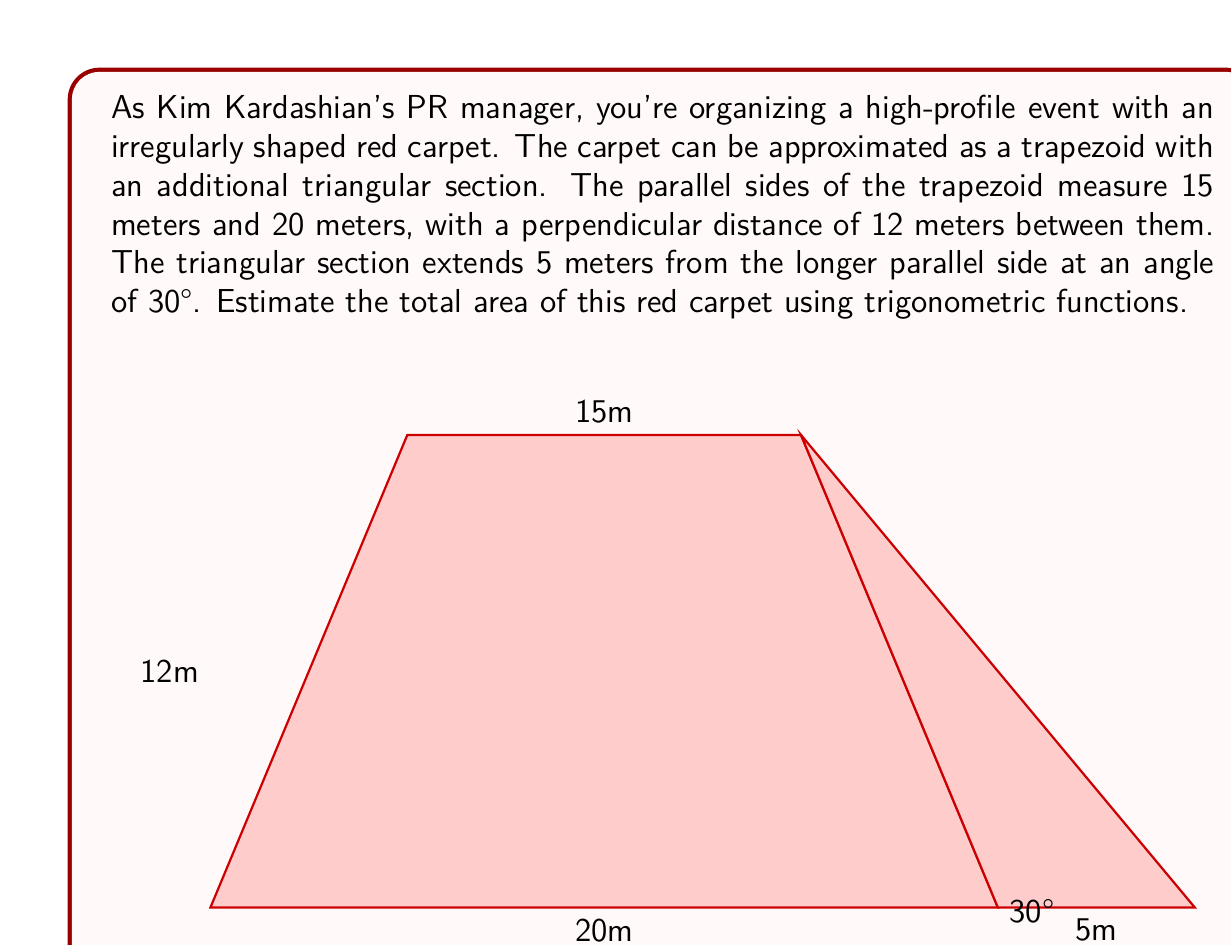Give your solution to this math problem. To solve this problem, we'll break it down into two parts: the trapezoid area and the triangular area.

1. Trapezoid Area:
   The area of a trapezoid is given by the formula: $A_t = \frac{1}{2}(b_1 + b_2)h$
   Where $b_1$ and $b_2$ are the parallel sides and $h$ is the height.
   
   $A_t = \frac{1}{2}(15 + 20) \times 12 = \frac{1}{2} \times 35 \times 12 = 210$ m²

2. Triangular Area:
   We need to find the height of the triangle using trigonometry.
   $\tan 30° = \frac{\text{height}}{\text{base}}$
   $\tan 30° = \frac{h}{5}$
   $h = 5 \tan 30°$
   
   We know that $\tan 30° = \frac{1}{\sqrt{3}}$, so:
   $h = 5 \times \frac{1}{\sqrt{3}} = \frac{5}{\sqrt{3}}$ meters

   Now we can calculate the area of the triangle:
   $A_{tri} = \frac{1}{2} \times \text{base} \times \text{height}$
   $A_{tri} = \frac{1}{2} \times 5 \times \frac{5}{\sqrt{3}} = \frac{25}{2\sqrt{3}}$ m²

3. Total Area:
   $A_{total} = A_t + A_{tri} = 210 + \frac{25}{2\sqrt{3}}$ m²

   To simplify, let's approximate $\frac{1}{\sqrt{3}}$ to 0.577:
   $A_{total} \approx 210 + \frac{25}{2} \times 0.577 \approx 210 + 7.21 \approx 217.21$ m²
Answer: The estimated total area of the red carpet is approximately 217.21 square meters. 